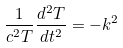Convert formula to latex. <formula><loc_0><loc_0><loc_500><loc_500>\frac { 1 } { c ^ { 2 } T } \frac { d ^ { 2 } T } { d t ^ { 2 } } = - k ^ { 2 }</formula> 